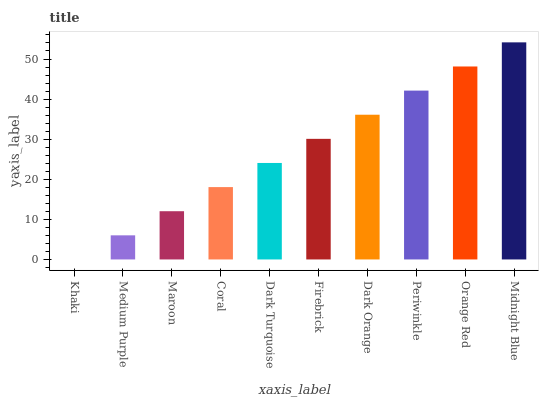Is Khaki the minimum?
Answer yes or no. Yes. Is Midnight Blue the maximum?
Answer yes or no. Yes. Is Medium Purple the minimum?
Answer yes or no. No. Is Medium Purple the maximum?
Answer yes or no. No. Is Medium Purple greater than Khaki?
Answer yes or no. Yes. Is Khaki less than Medium Purple?
Answer yes or no. Yes. Is Khaki greater than Medium Purple?
Answer yes or no. No. Is Medium Purple less than Khaki?
Answer yes or no. No. Is Firebrick the high median?
Answer yes or no. Yes. Is Dark Turquoise the low median?
Answer yes or no. Yes. Is Coral the high median?
Answer yes or no. No. Is Khaki the low median?
Answer yes or no. No. 